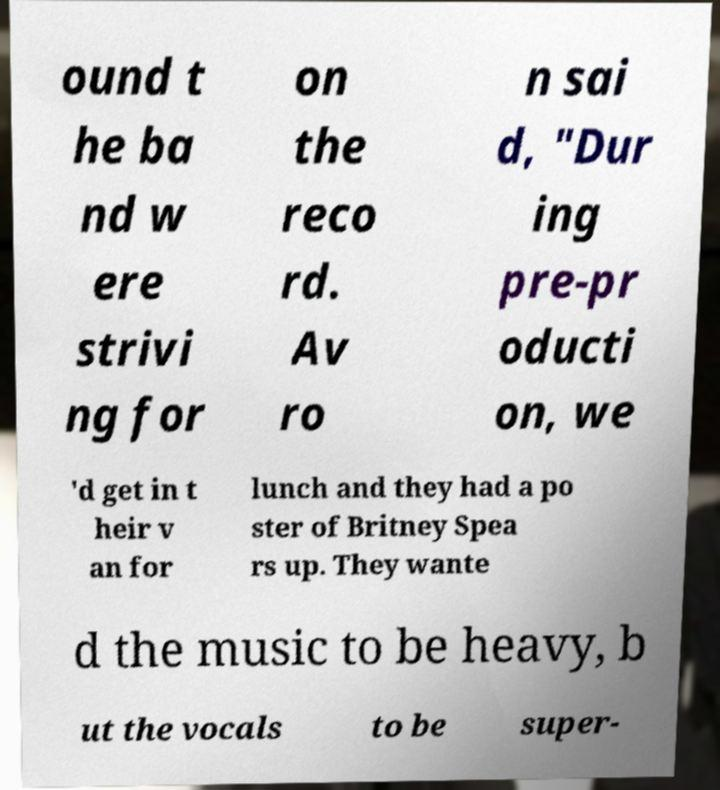There's text embedded in this image that I need extracted. Can you transcribe it verbatim? ound t he ba nd w ere strivi ng for on the reco rd. Av ro n sai d, "Dur ing pre-pr oducti on, we 'd get in t heir v an for lunch and they had a po ster of Britney Spea rs up. They wante d the music to be heavy, b ut the vocals to be super- 